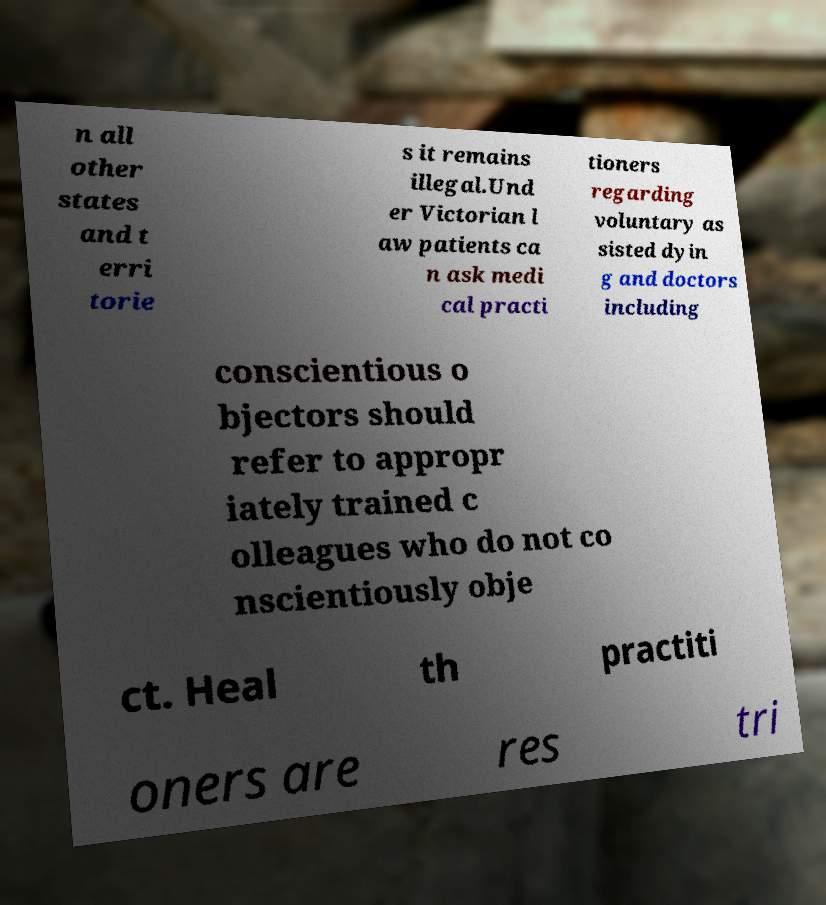I need the written content from this picture converted into text. Can you do that? n all other states and t erri torie s it remains illegal.Und er Victorian l aw patients ca n ask medi cal practi tioners regarding voluntary as sisted dyin g and doctors including conscientious o bjectors should refer to appropr iately trained c olleagues who do not co nscientiously obje ct. Heal th practiti oners are res tri 